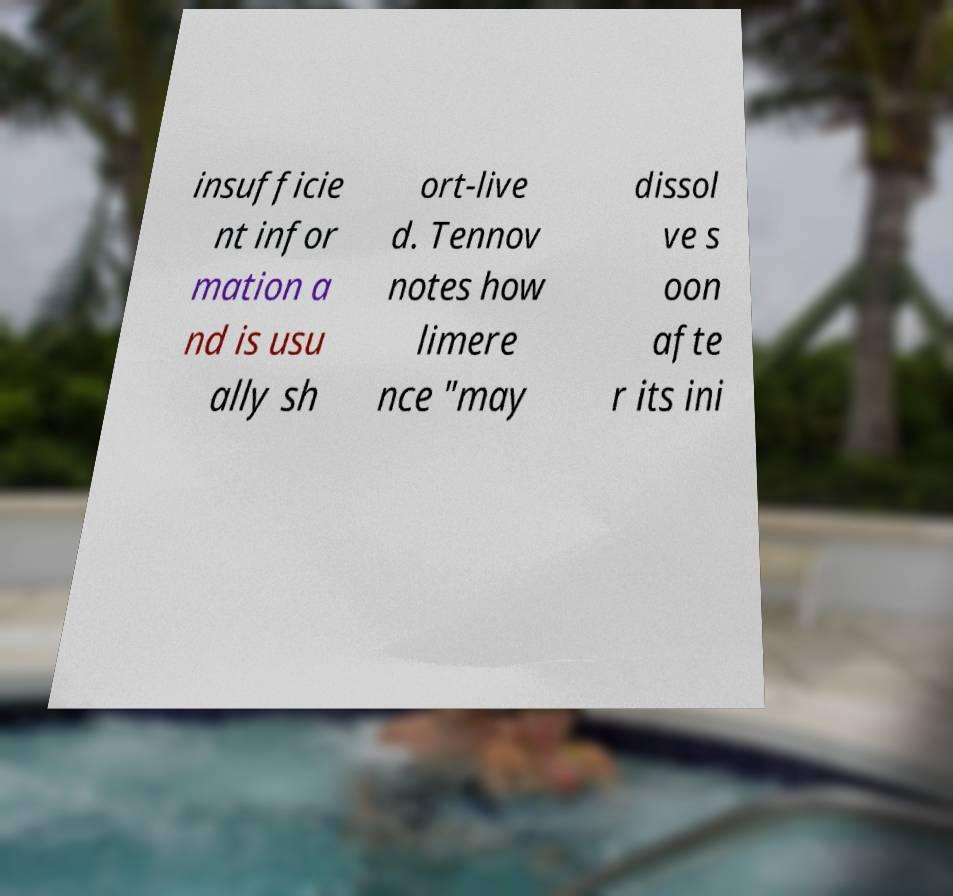Can you accurately transcribe the text from the provided image for me? insufficie nt infor mation a nd is usu ally sh ort-live d. Tennov notes how limere nce "may dissol ve s oon afte r its ini 